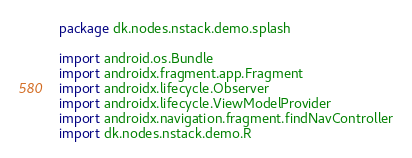Convert code to text. <code><loc_0><loc_0><loc_500><loc_500><_Kotlin_>package dk.nodes.nstack.demo.splash

import android.os.Bundle
import androidx.fragment.app.Fragment
import androidx.lifecycle.Observer
import androidx.lifecycle.ViewModelProvider
import androidx.navigation.fragment.findNavController
import dk.nodes.nstack.demo.R</code> 